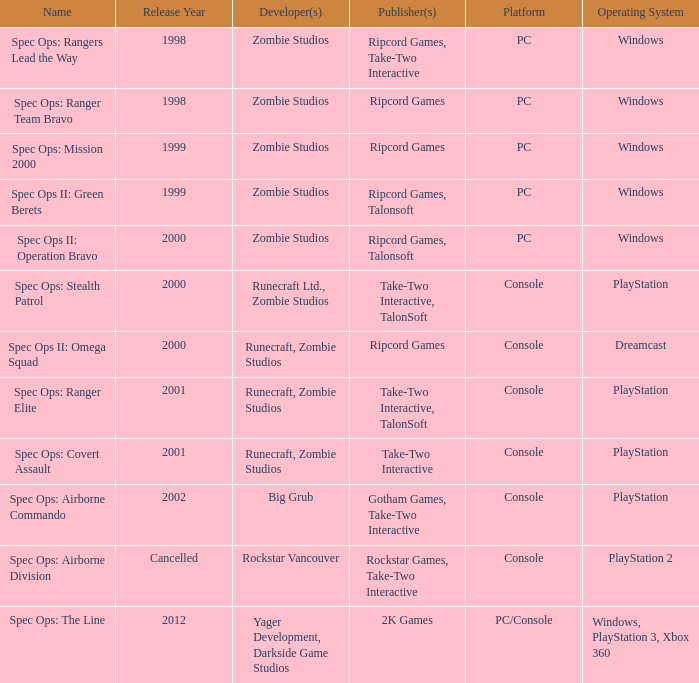Which publisher is responsible for spec ops: stealth patrol? Take-Two Interactive , TalonSoft. 